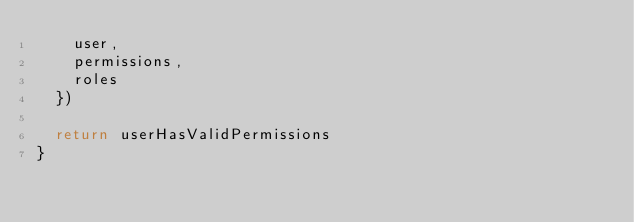Convert code to text. <code><loc_0><loc_0><loc_500><loc_500><_TypeScript_>    user,
    permissions,
    roles
  })

  return userHasValidPermissions
}</code> 